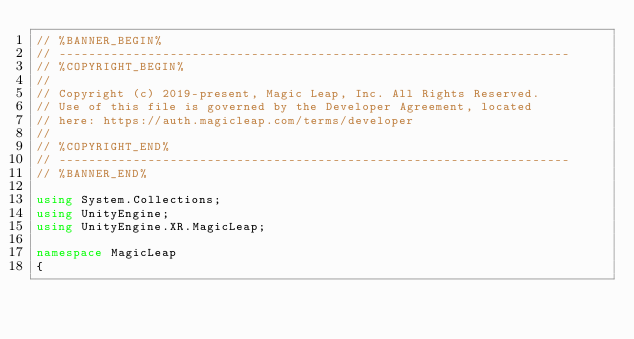<code> <loc_0><loc_0><loc_500><loc_500><_C#_>// %BANNER_BEGIN%
// ---------------------------------------------------------------------
// %COPYRIGHT_BEGIN%
//
// Copyright (c) 2019-present, Magic Leap, Inc. All Rights Reserved.
// Use of this file is governed by the Developer Agreement, located
// here: https://auth.magicleap.com/terms/developer
//
// %COPYRIGHT_END%
// ---------------------------------------------------------------------
// %BANNER_END%

using System.Collections;
using UnityEngine;
using UnityEngine.XR.MagicLeap;

namespace MagicLeap
{</code> 